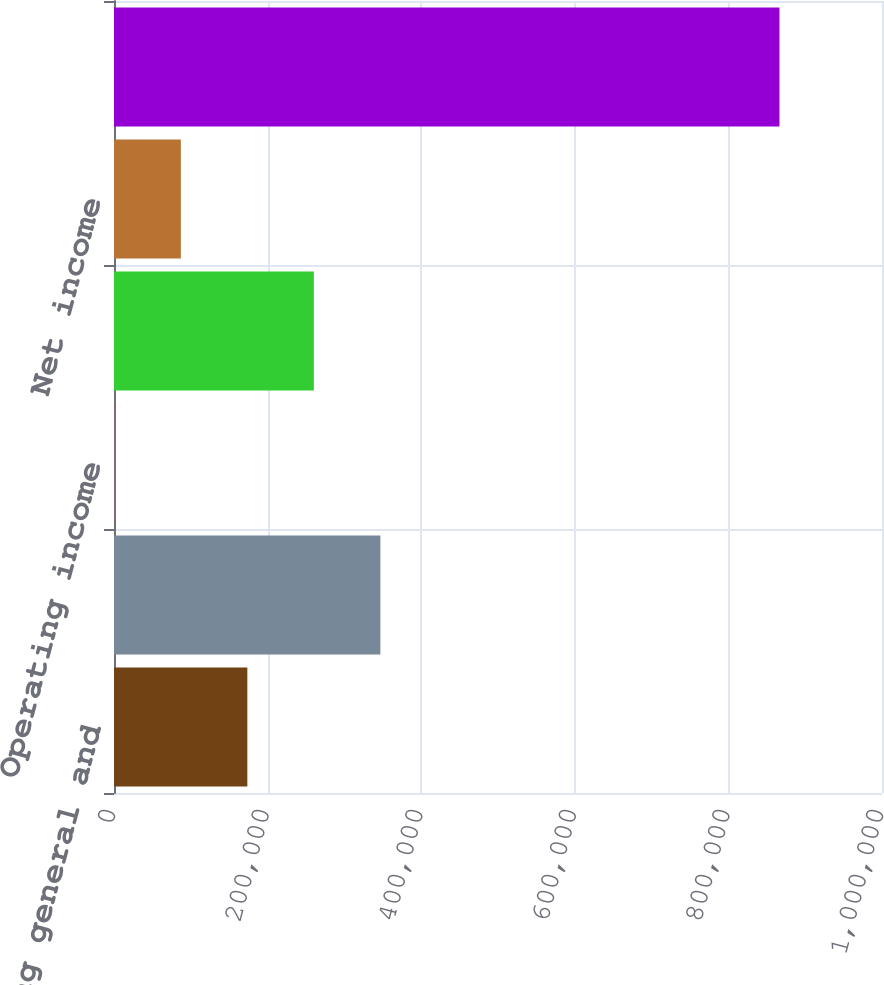Convert chart. <chart><loc_0><loc_0><loc_500><loc_500><bar_chart><fcel>Selling general and<fcel>Total operating expenses<fcel>Operating income<fcel>Income before provision for<fcel>Net income<fcel>Diluted<nl><fcel>173630<fcel>346843<fcel>417<fcel>260237<fcel>87023.6<fcel>866483<nl></chart> 